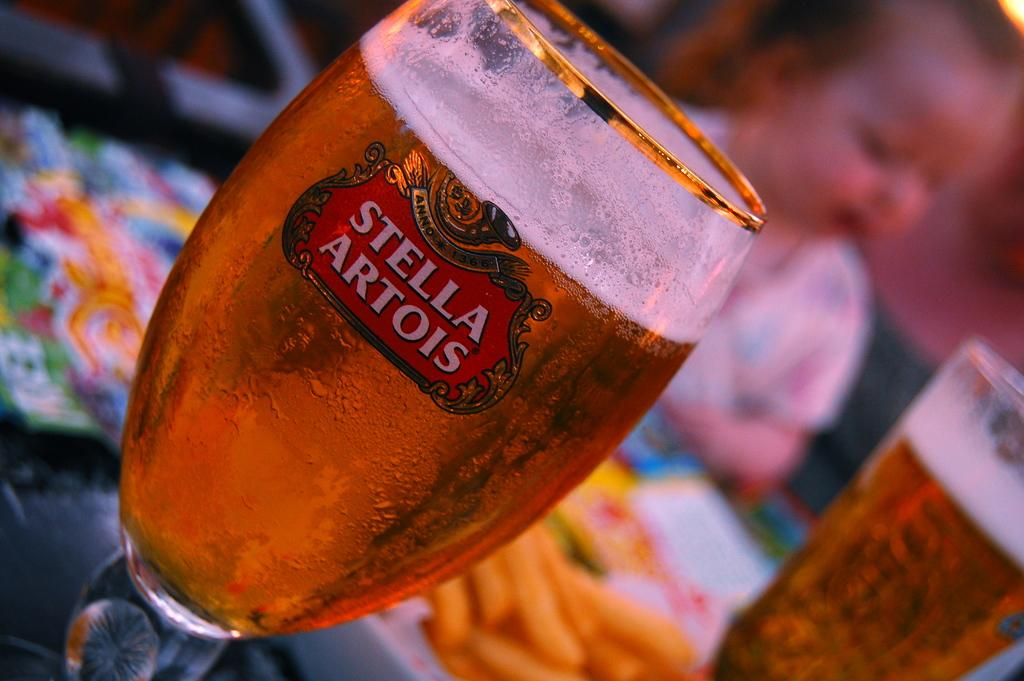Provide a one-sentence caption for the provided image. A glass filled with liquid and the writing "Stella Artois" on the front. 